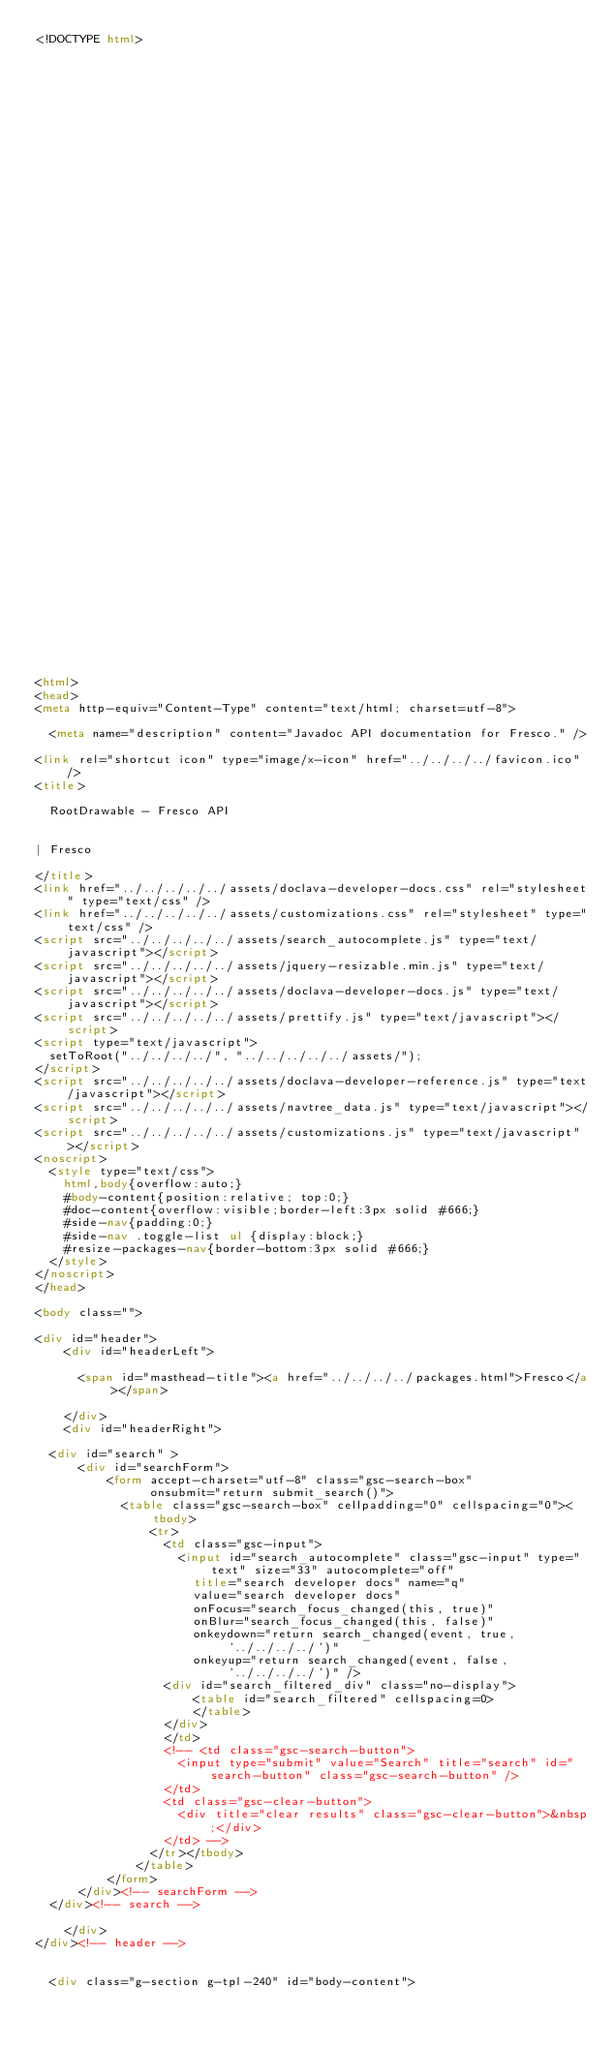Convert code to text. <code><loc_0><loc_0><loc_500><loc_500><_HTML_><!DOCTYPE html>

















































<html>
<head>
<meta http-equiv="Content-Type" content="text/html; charset=utf-8">

  <meta name="description" content="Javadoc API documentation for Fresco." />

<link rel="shortcut icon" type="image/x-icon" href="../../../../favicon.ico" />
<title>

  RootDrawable - Fresco API


| Fresco

</title>
<link href="../../../../../assets/doclava-developer-docs.css" rel="stylesheet" type="text/css" />
<link href="../../../../../assets/customizations.css" rel="stylesheet" type="text/css" />
<script src="../../../../../assets/search_autocomplete.js" type="text/javascript"></script>
<script src="../../../../../assets/jquery-resizable.min.js" type="text/javascript"></script>
<script src="../../../../../assets/doclava-developer-docs.js" type="text/javascript"></script>
<script src="../../../../../assets/prettify.js" type="text/javascript"></script>
<script type="text/javascript">
  setToRoot("../../../../", "../../../../../assets/");
</script>
<script src="../../../../../assets/doclava-developer-reference.js" type="text/javascript"></script>
<script src="../../../../../assets/navtree_data.js" type="text/javascript"></script>
<script src="../../../../../assets/customizations.js" type="text/javascript"></script>
<noscript>
  <style type="text/css">
    html,body{overflow:auto;}
    #body-content{position:relative; top:0;}
    #doc-content{overflow:visible;border-left:3px solid #666;}
    #side-nav{padding:0;}
    #side-nav .toggle-list ul {display:block;}
    #resize-packages-nav{border-bottom:3px solid #666;}
  </style>
</noscript>
</head>

<body class="">

<div id="header">
    <div id="headerLeft">
    
      <span id="masthead-title"><a href="../../../../packages.html">Fresco</a></span>
    
    </div>
    <div id="headerRight">
      
  <div id="search" >
      <div id="searchForm">
          <form accept-charset="utf-8" class="gsc-search-box" 
                onsubmit="return submit_search()">
            <table class="gsc-search-box" cellpadding="0" cellspacing="0"><tbody>
                <tr>
                  <td class="gsc-input">
                    <input id="search_autocomplete" class="gsc-input" type="text" size="33" autocomplete="off"
                      title="search developer docs" name="q"
                      value="search developer docs"
                      onFocus="search_focus_changed(this, true)"
                      onBlur="search_focus_changed(this, false)"
                      onkeydown="return search_changed(event, true, '../../../../')"
                      onkeyup="return search_changed(event, false, '../../../../')" />
                  <div id="search_filtered_div" class="no-display">
                      <table id="search_filtered" cellspacing=0>
                      </table>
                  </div>
                  </td>
                  <!-- <td class="gsc-search-button">
                    <input type="submit" value="Search" title="search" id="search-button" class="gsc-search-button" />
                  </td>
                  <td class="gsc-clear-button">
                    <div title="clear results" class="gsc-clear-button">&nbsp;</div>
                  </td> -->
                </tr></tbody>
              </table>
          </form>
      </div><!-- searchForm -->
  </div><!-- search -->
      
    </div>
</div><!-- header -->


  <div class="g-section g-tpl-240" id="body-content"></code> 